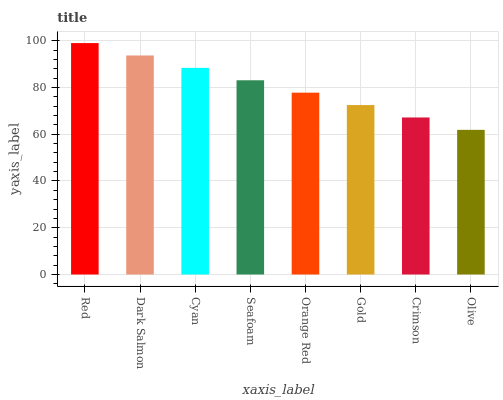Is Dark Salmon the minimum?
Answer yes or no. No. Is Dark Salmon the maximum?
Answer yes or no. No. Is Red greater than Dark Salmon?
Answer yes or no. Yes. Is Dark Salmon less than Red?
Answer yes or no. Yes. Is Dark Salmon greater than Red?
Answer yes or no. No. Is Red less than Dark Salmon?
Answer yes or no. No. Is Seafoam the high median?
Answer yes or no. Yes. Is Orange Red the low median?
Answer yes or no. Yes. Is Olive the high median?
Answer yes or no. No. Is Crimson the low median?
Answer yes or no. No. 